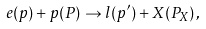Convert formula to latex. <formula><loc_0><loc_0><loc_500><loc_500>e ( p ) + p ( P ) \to l ( p ^ { \prime } ) + X ( P _ { X } ) \, ,</formula> 